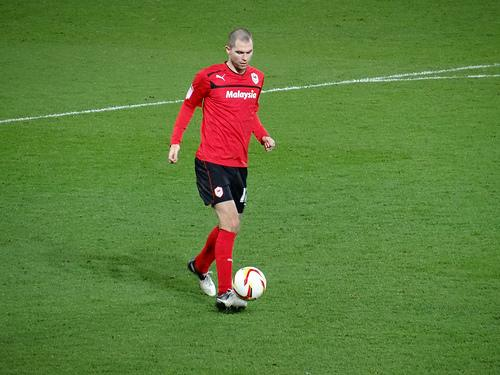Examine the image and list the colors of the player's outfit, including their shirt, shorts, socks, and shoes. The player is wearing a red shirt, black shorts with a red pinstripe, red socks, and gray and black shoes. What is the condition of the grass field in the image and are there any markings on it? The grass field is green and appears well-maintained, with white chalk lines marking the soccer field. Identify the color and design of the soccer player's shirt in the image. The soccer player is wearing a red long sleeve shirt with a black stripe. How is the soccer player interacting with the ball? The soccer player is looking down at the ball, preparing to kick it with his gray and black shoes. What type of field is the player on, and what is the player kicking? The player is on a green grass soccer field, kicking a white soccer ball with curved red lines. Estimate the number of visible objects in the image that are directly related to the soccer player and the sport. There are around 20 objects directly related to the soccer player and the sport, including the ball, the player's apparel, and the field markings. In the image, determine the color and shape of the soccer ball and where it is located in relation to the player. The soccer ball is white with curved red lines and is located near the man's feet. Describe any visible logos or symbols present on the player's clothing. There are white logos on the black shorts and the red shirt, as well as a white puma on the jersey. What type of sport is the person playing and what is unusual about their uniform? The person is playing soccer, and their red shirt has long sleeves, which is not typical soccer attire. What does the player's hair look like and what is written on his shirt? The player has short, thinning black hair, and there is white writing on his red shirt. Analyze the interactions between the soccer player and the ball. The man is kicking the soccer ball near his feet, with an observable interaction between the player and the ball. Point out the exact location of the player's ear in the image. X:223 Y:43 Width:7 Height:7 Do you see the small unicorn mascot on the red shirt just below the collar? It's white with a purple mane. No, it's not mentioned in the image. Describe the section of green grass in the image. There's a section of green grass at X:310 Y:168 with Width:176 Height:176. Is the player wearing shoes or boots? The player is wearing gray and black shoes. Describe the scene in the image. A soccer player in a red and black uniform is kicking a white, red, and yellow soccer ball on a green grass field with white chalk lines. What is the name of the team displayed in white on the player's shirt? The team name is not visible in the image. Find and describe the logo on the player's jersey. There is a white puma logo on the red shirt. Determine if the player is wearing long sleeves or short sleeves. The player is wearing long sleeves. Based on the player's hair, classify it as short or long. The player has short hair. Are there any white chalk lines on the grass field? Yes, there are white chalk lines on the green grass field. Identify the emotion or sentiment portrayed by the soccer player. The soccer player appears focused and engaged in the game. In the image, locate the player's left knee. X:201 Y:202 Width:45 Height:45 Examine if there are any unusual elements or anomalies present in the image. There are no unusual elements or anomalies detected. Identify the color and the design of the soccer ball. The soccer ball is white with red curved lines. Identify the different types of stripes present on the player's uniform. There's a black stripe on the shirt and a red pinstripe on the shorts. Assess the overall quality of the image in terms of sharpness and contrast. The image has good sharpness and color contrast. What color and type of shirt is the man wearing? The man is wearing a red long sleeve shirt with a black stripe. List all the objects you see in the image. green soccer field, shadow, white soccer ball, gray and black shoes, red socks, black shorts, red long sleeve shirt, black stripe, white chalk lines, thinning black hair, white logos, short hair, white puma, long sleeves, red stripe on shorts, green grass, soccer player's head. Which brand logo can be seen on the player's jersey? Puma. Count how many different colors are on the soccer ball. There are two colors: white and red. 